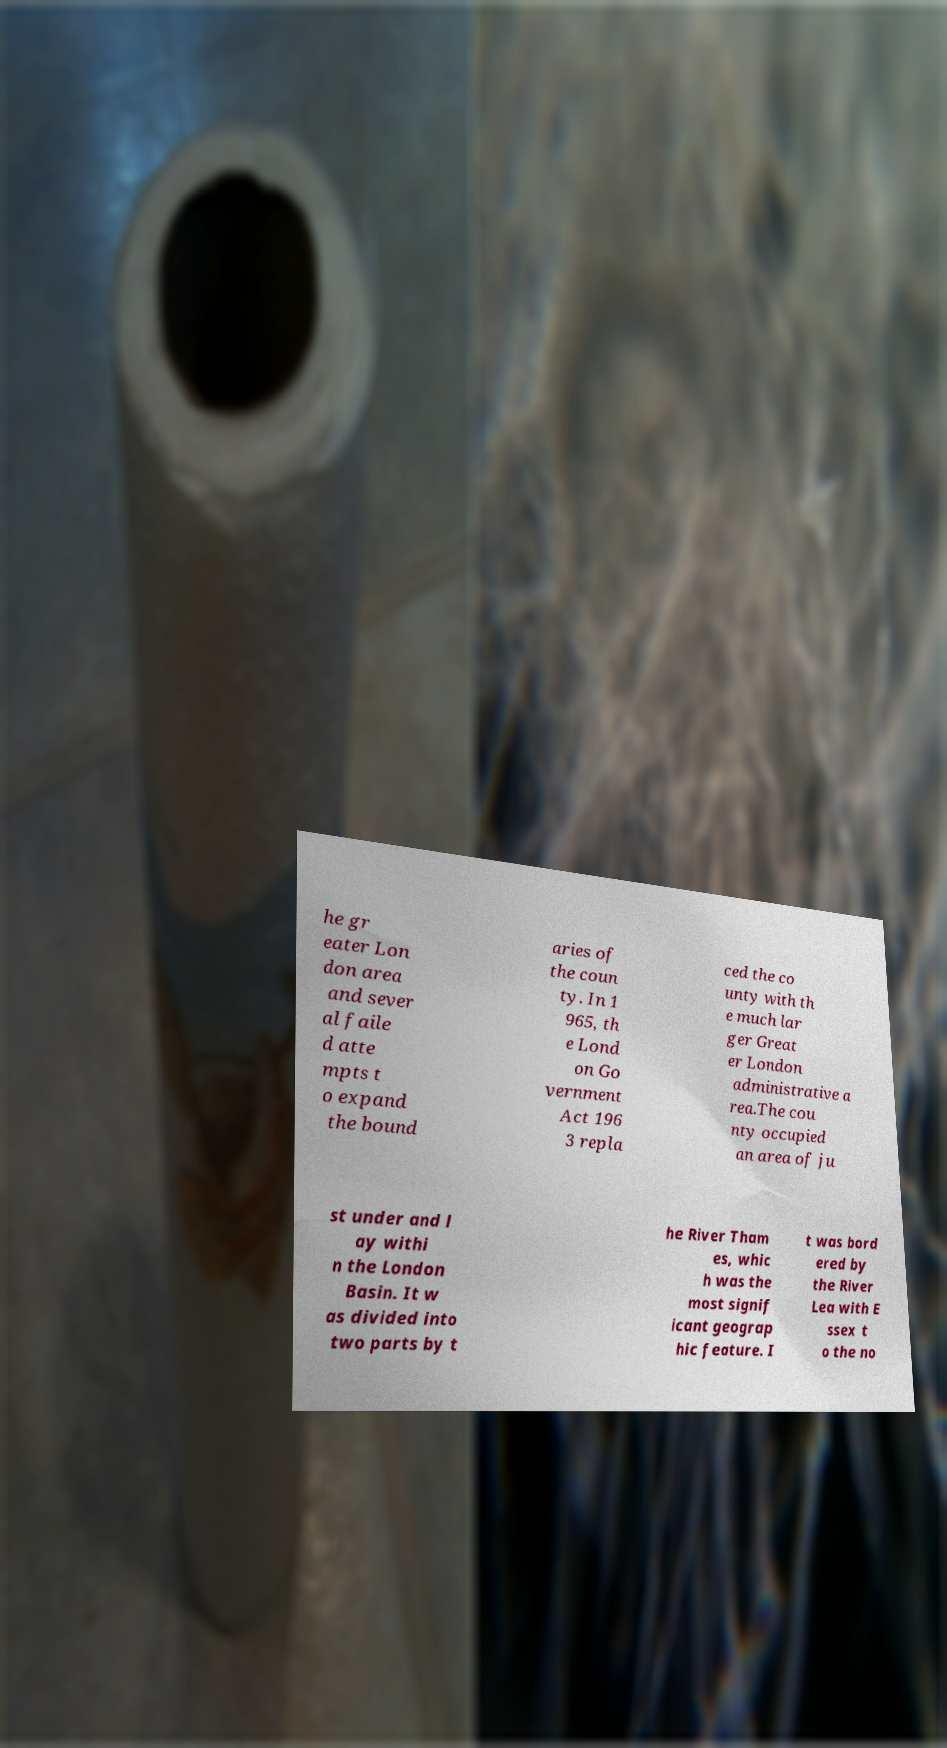For documentation purposes, I need the text within this image transcribed. Could you provide that? he gr eater Lon don area and sever al faile d atte mpts t o expand the bound aries of the coun ty. In 1 965, th e Lond on Go vernment Act 196 3 repla ced the co unty with th e much lar ger Great er London administrative a rea.The cou nty occupied an area of ju st under and l ay withi n the London Basin. It w as divided into two parts by t he River Tham es, whic h was the most signif icant geograp hic feature. I t was bord ered by the River Lea with E ssex t o the no 